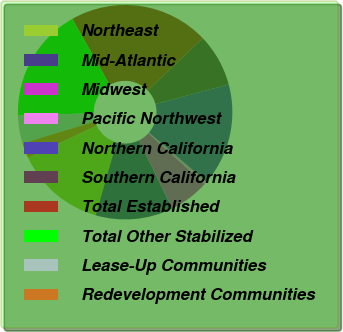Convert chart. <chart><loc_0><loc_0><loc_500><loc_500><pie_chart><fcel>Northeast<fcel>Mid-Atlantic<fcel>Midwest<fcel>Pacific Northwest<fcel>Northern California<fcel>Southern California<fcel>Total Established<fcel>Total Other Stabilized<fcel>Lease-Up Communities<fcel>Redevelopment Communities<nl><fcel>13.56%<fcel>11.69%<fcel>6.06%<fcel>0.43%<fcel>15.44%<fcel>7.94%<fcel>21.07%<fcel>17.32%<fcel>4.18%<fcel>2.31%<nl></chart> 